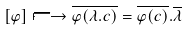Convert formula to latex. <formula><loc_0><loc_0><loc_500><loc_500>[ \varphi ] \longmapsto \overline { \varphi ( \lambda . c ) } = \overline { \varphi ( c ) } . \overline { \lambda }</formula> 